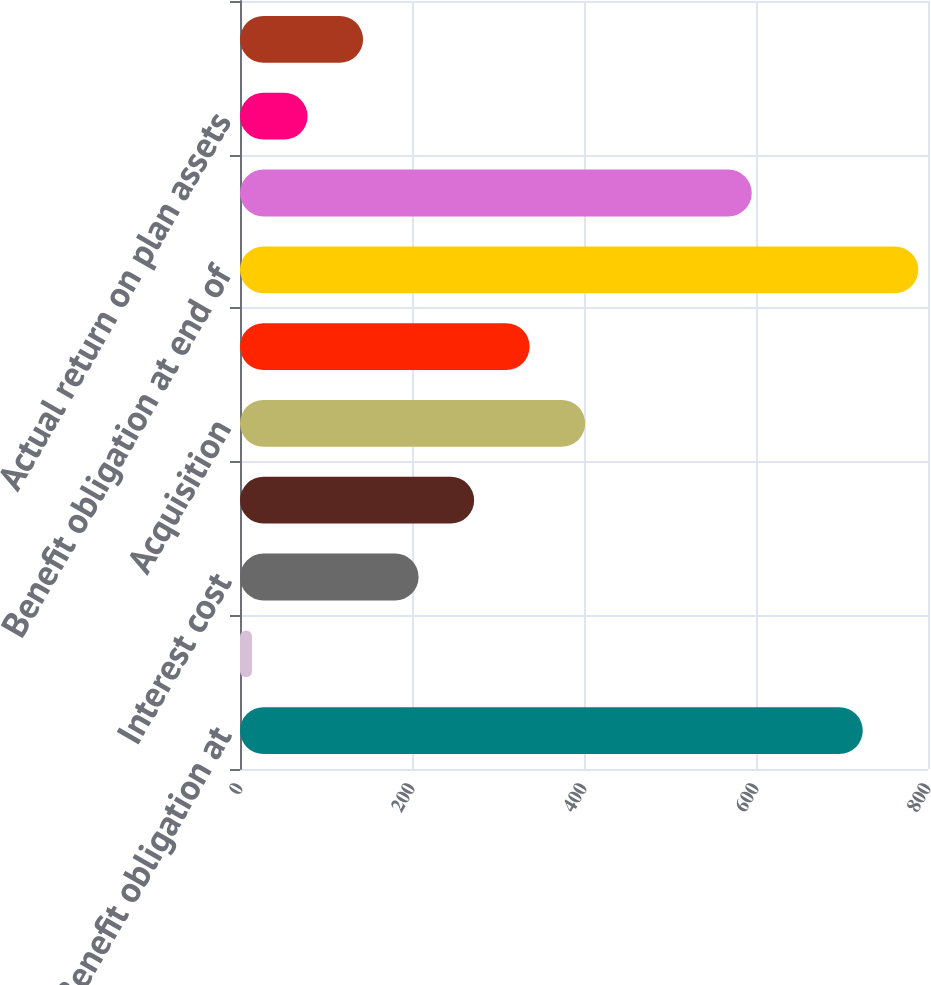Convert chart to OTSL. <chart><loc_0><loc_0><loc_500><loc_500><bar_chart><fcel>Benefit obligation at<fcel>Service cost<fcel>Interest cost<fcel>Benefits paid and other<fcel>Acquisition<fcel>Actuarial loss (gain)<fcel>Benefit obligation at end of<fcel>Fair value of plan assets at<fcel>Actual return on plan assets<fcel>Employer contributions<nl><fcel>724.16<fcel>14<fcel>207.68<fcel>272.24<fcel>401.36<fcel>336.8<fcel>788.72<fcel>595.04<fcel>78.56<fcel>143.12<nl></chart> 